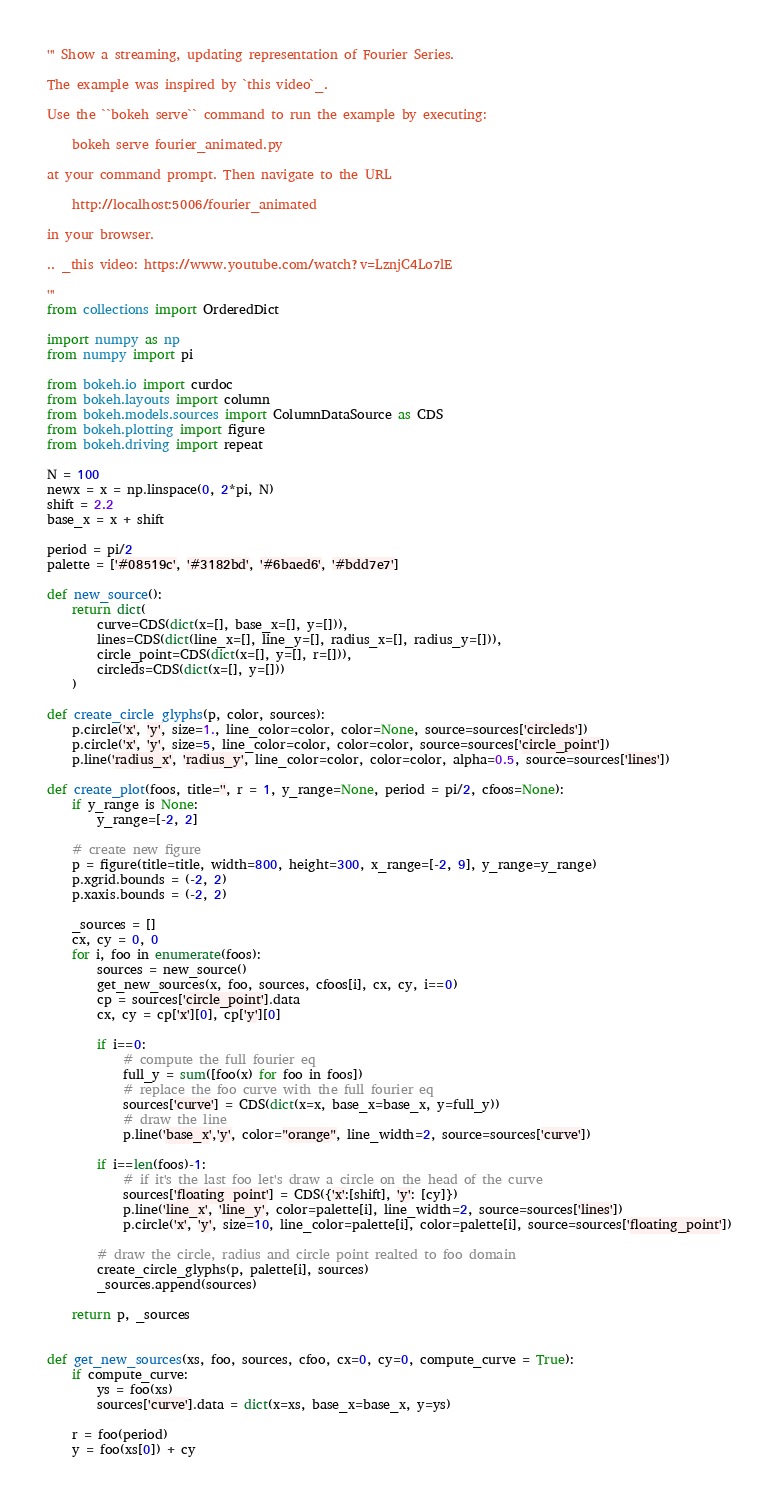Convert code to text. <code><loc_0><loc_0><loc_500><loc_500><_Python_>''' Show a streaming, updating representation of Fourier Series.

The example was inspired by `this video`_.

Use the ``bokeh serve`` command to run the example by executing:

    bokeh serve fourier_animated.py

at your command prompt. Then navigate to the URL

    http://localhost:5006/fourier_animated

in your browser.

.. _this video: https://www.youtube.com/watch?v=LznjC4Lo7lE

'''
from collections import OrderedDict

import numpy as np
from numpy import pi

from bokeh.io import curdoc
from bokeh.layouts import column
from bokeh.models.sources import ColumnDataSource as CDS
from bokeh.plotting import figure
from bokeh.driving import repeat

N = 100
newx = x = np.linspace(0, 2*pi, N)
shift = 2.2
base_x = x + shift

period = pi/2
palette = ['#08519c', '#3182bd', '#6baed6', '#bdd7e7']

def new_source():
    return dict(
        curve=CDS(dict(x=[], base_x=[], y=[])),
        lines=CDS(dict(line_x=[], line_y=[], radius_x=[], radius_y=[])),
        circle_point=CDS(dict(x=[], y=[], r=[])),
        circleds=CDS(dict(x=[], y=[]))
    )

def create_circle_glyphs(p, color, sources):
    p.circle('x', 'y', size=1., line_color=color, color=None, source=sources['circleds'])
    p.circle('x', 'y', size=5, line_color=color, color=color, source=sources['circle_point'])
    p.line('radius_x', 'radius_y', line_color=color, color=color, alpha=0.5, source=sources['lines'])

def create_plot(foos, title='', r = 1, y_range=None, period = pi/2, cfoos=None):
    if y_range is None:
        y_range=[-2, 2]

    # create new figure
    p = figure(title=title, width=800, height=300, x_range=[-2, 9], y_range=y_range)
    p.xgrid.bounds = (-2, 2)
    p.xaxis.bounds = (-2, 2)

    _sources = []
    cx, cy = 0, 0
    for i, foo in enumerate(foos):
        sources = new_source()
        get_new_sources(x, foo, sources, cfoos[i], cx, cy, i==0)
        cp = sources['circle_point'].data
        cx, cy = cp['x'][0], cp['y'][0]

        if i==0:
            # compute the full fourier eq
            full_y = sum([foo(x) for foo in foos])
            # replace the foo curve with the full fourier eq
            sources['curve'] = CDS(dict(x=x, base_x=base_x, y=full_y))
            # draw the line
            p.line('base_x','y', color="orange", line_width=2, source=sources['curve'])

        if i==len(foos)-1:
            # if it's the last foo let's draw a circle on the head of the curve
            sources['floating_point'] = CDS({'x':[shift], 'y': [cy]})
            p.line('line_x', 'line_y', color=palette[i], line_width=2, source=sources['lines'])
            p.circle('x', 'y', size=10, line_color=palette[i], color=palette[i], source=sources['floating_point'])

        # draw the circle, radius and circle point realted to foo domain
        create_circle_glyphs(p, palette[i], sources)
        _sources.append(sources)

    return p, _sources


def get_new_sources(xs, foo, sources, cfoo, cx=0, cy=0, compute_curve = True):
    if compute_curve:
        ys = foo(xs)
        sources['curve'].data = dict(x=xs, base_x=base_x, y=ys)

    r = foo(period)
    y = foo(xs[0]) + cy</code> 